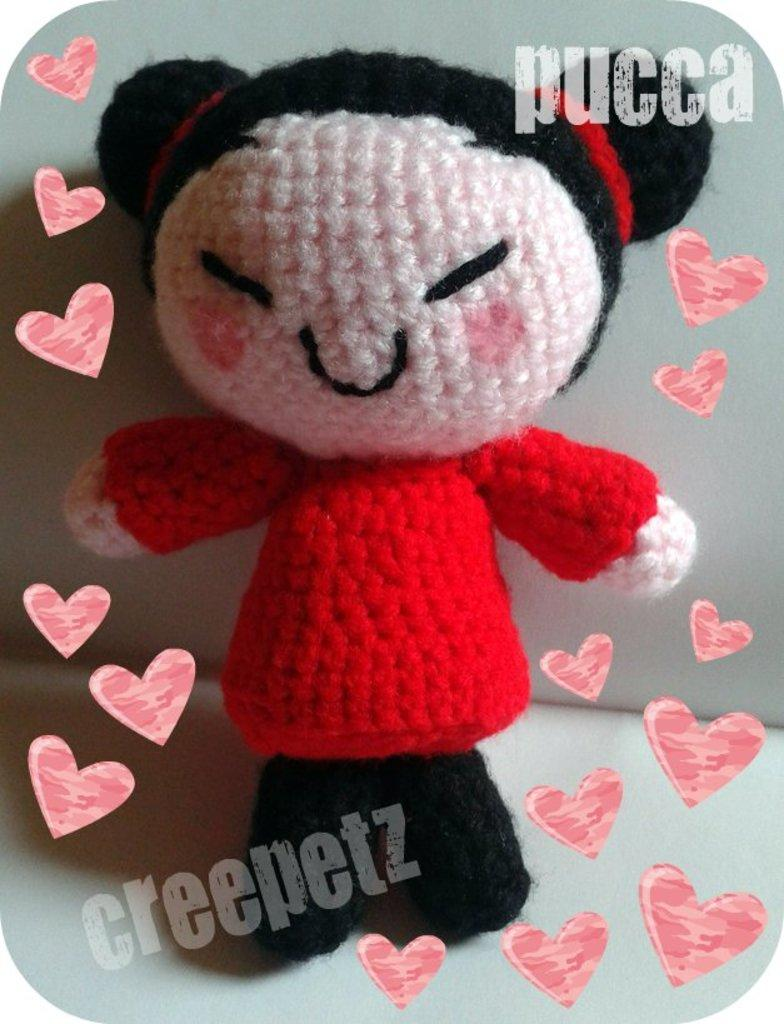What type of editing has been done to the image? The image is edited, but the specific type of editing is not mentioned in the facts. What object is present in the image? There is a doll in the image. What color is the background of the image? The background of the image is white. Are there any visible marks on the image? Yes, there are watermarks on the image. What time of day is the event taking place in the image? There is no event or time of day mentioned in the image, as it only features a doll and a white background. 